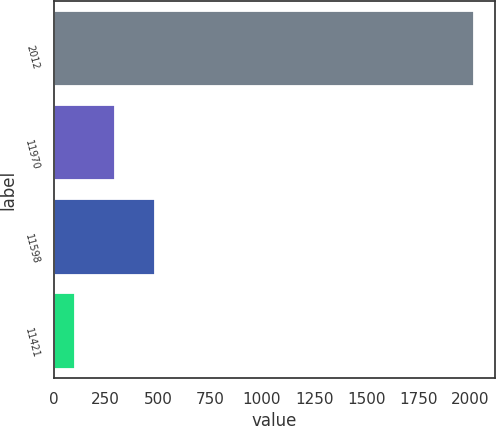Convert chart. <chart><loc_0><loc_0><loc_500><loc_500><bar_chart><fcel>2012<fcel>11970<fcel>11598<fcel>11421<nl><fcel>2016<fcel>294.32<fcel>485.62<fcel>103.02<nl></chart> 